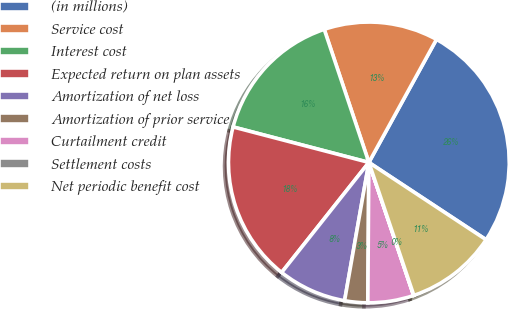<chart> <loc_0><loc_0><loc_500><loc_500><pie_chart><fcel>(in millions)<fcel>Service cost<fcel>Interest cost<fcel>Expected return on plan assets<fcel>Amortization of net loss<fcel>Amortization of prior service<fcel>Curtailment credit<fcel>Settlement costs<fcel>Net periodic benefit cost<nl><fcel>26.28%<fcel>13.15%<fcel>15.78%<fcel>18.4%<fcel>7.9%<fcel>2.65%<fcel>5.28%<fcel>0.03%<fcel>10.53%<nl></chart> 